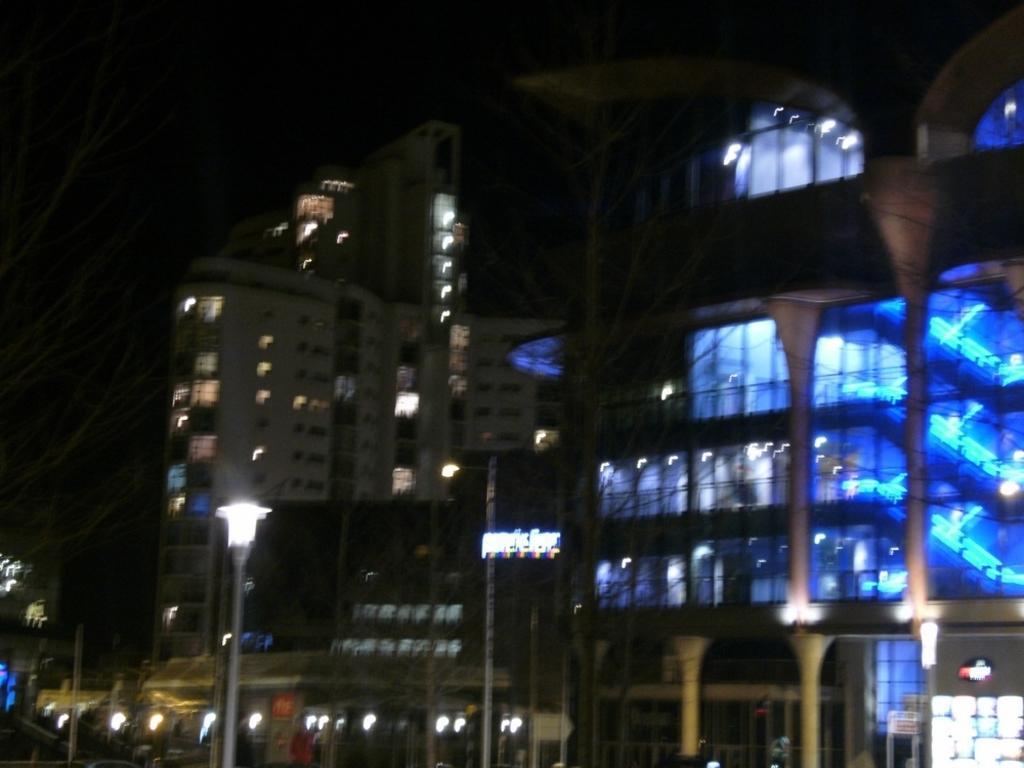Please provide a concise description of this image. In this image we can see buildings with lights and a street light. 